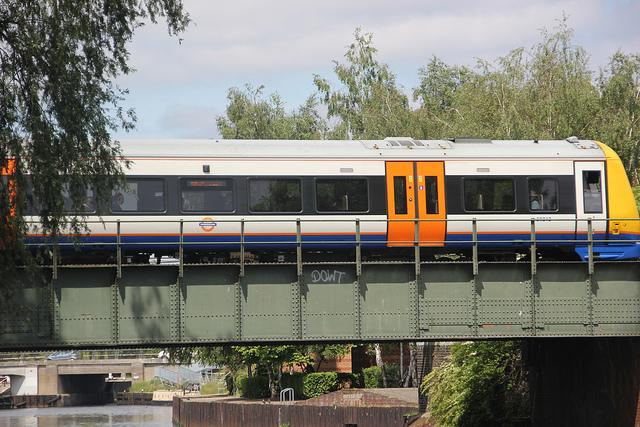The train gliding on what in order to move? Please explain your reasoning. rails. There are rails there for the train to run on. 